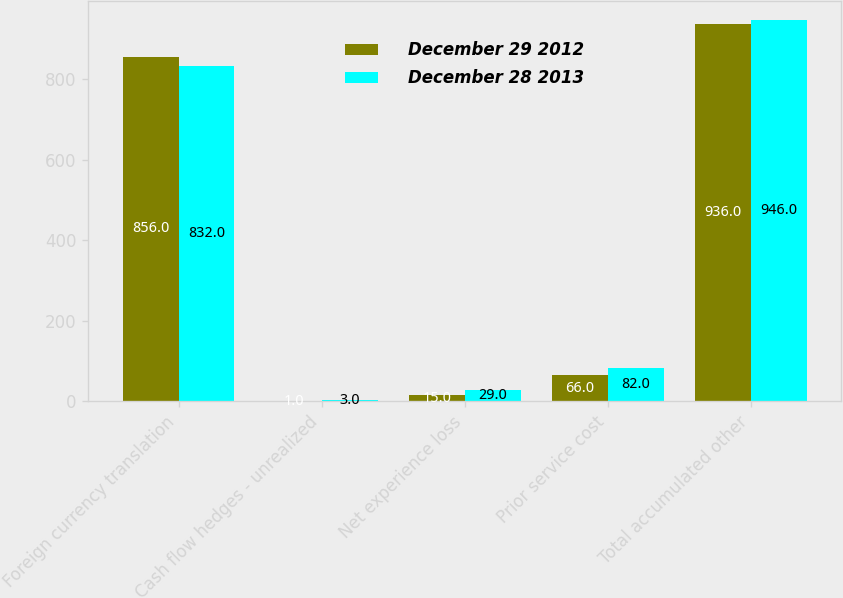Convert chart to OTSL. <chart><loc_0><loc_0><loc_500><loc_500><stacked_bar_chart><ecel><fcel>Foreign currency translation<fcel>Cash flow hedges - unrealized<fcel>Net experience loss<fcel>Prior service cost<fcel>Total accumulated other<nl><fcel>December 29 2012<fcel>856<fcel>1<fcel>15<fcel>66<fcel>936<nl><fcel>December 28 2013<fcel>832<fcel>3<fcel>29<fcel>82<fcel>946<nl></chart> 